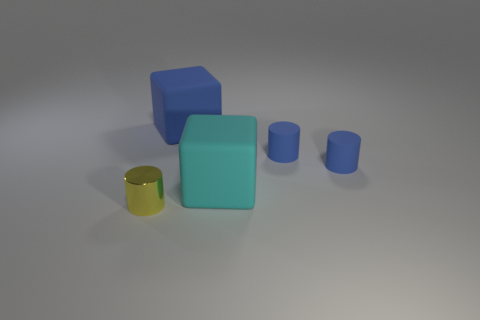Subtract all small blue cylinders. How many cylinders are left? 1 Add 2 tiny matte cylinders. How many objects exist? 7 Subtract all yellow cylinders. How many cylinders are left? 2 Subtract all brown spheres. How many blue cylinders are left? 2 Add 3 blue matte blocks. How many blue matte blocks exist? 4 Subtract 0 gray cubes. How many objects are left? 5 Subtract all cylinders. How many objects are left? 2 Subtract 1 blocks. How many blocks are left? 1 Subtract all brown cylinders. Subtract all cyan spheres. How many cylinders are left? 3 Subtract all blue rubber cubes. Subtract all small yellow cylinders. How many objects are left? 3 